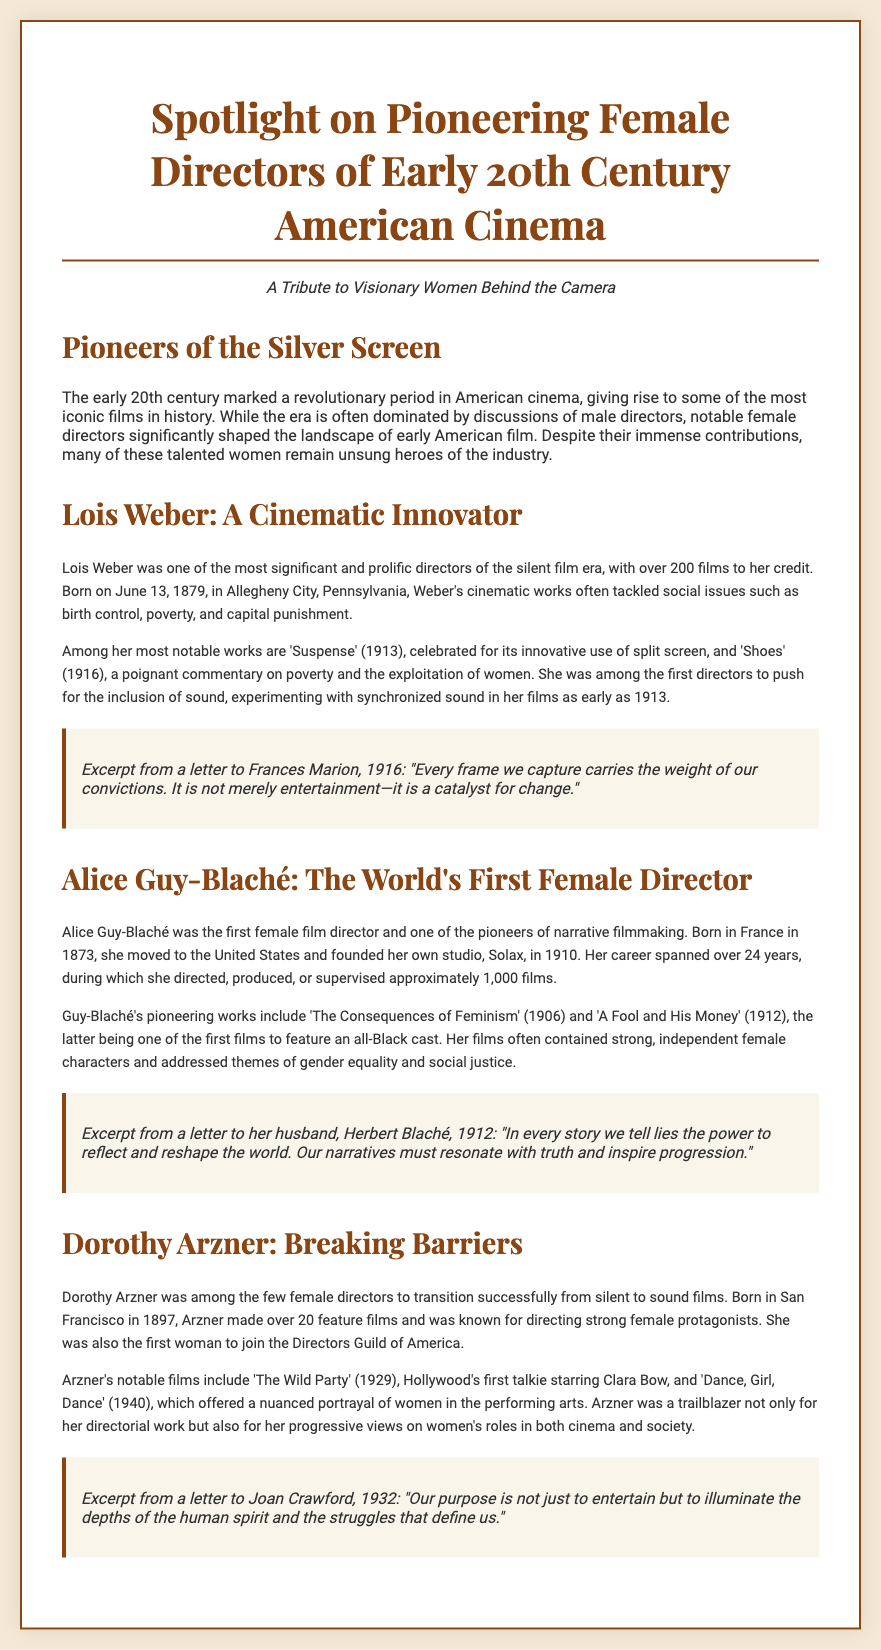What is the title of the Playbill? The title is prominently displayed at the top of the document.
Answer: Spotlight on Pioneering Female Directors of Early 20th Century American Cinema Who is the first female film director mentioned? The biography section highlights Alice Guy-Blaché as the first female director.
Answer: Alice Guy-Blaché How many films did Lois Weber direct? The document states that Lois Weber directed over 200 films.
Answer: over 200 What year did Alice Guy-Blaché found her studio? The text specifies that she founded her studio in 1910.
Answer: 1910 Which film is noted as Hollywood's first talkie starring Clara Bow? Dorothy Arzner's works mention this film as a significant milestone in sound films.
Answer: The Wild Party What social issue did Lois Weber's films often address? The biography discusses several themes, one of which is poverty.
Answer: poverty How many feature films did Dorothy Arzner direct? The biography section indicates that she made over 20 feature films.
Answer: over 20 What is a common theme found in Alice Guy-Blaché's films? The document notes that her films often address themes of gender equality.
Answer: gender equality What organization was Dorothy Arzner the first woman to join? The document mentions her joining a notable film organization as a significant achievement.
Answer: Directors Guild of America 